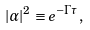Convert formula to latex. <formula><loc_0><loc_0><loc_500><loc_500>| \alpha | ^ { 2 } \equiv e ^ { - \Gamma \tau } ,</formula> 